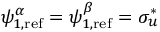<formula> <loc_0><loc_0><loc_500><loc_500>\psi _ { 1 , r e f } ^ { \alpha } = \psi _ { 1 , r e f } ^ { \beta } = \sigma _ { u } ^ { * }</formula> 